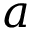Convert formula to latex. <formula><loc_0><loc_0><loc_500><loc_500>a</formula> 